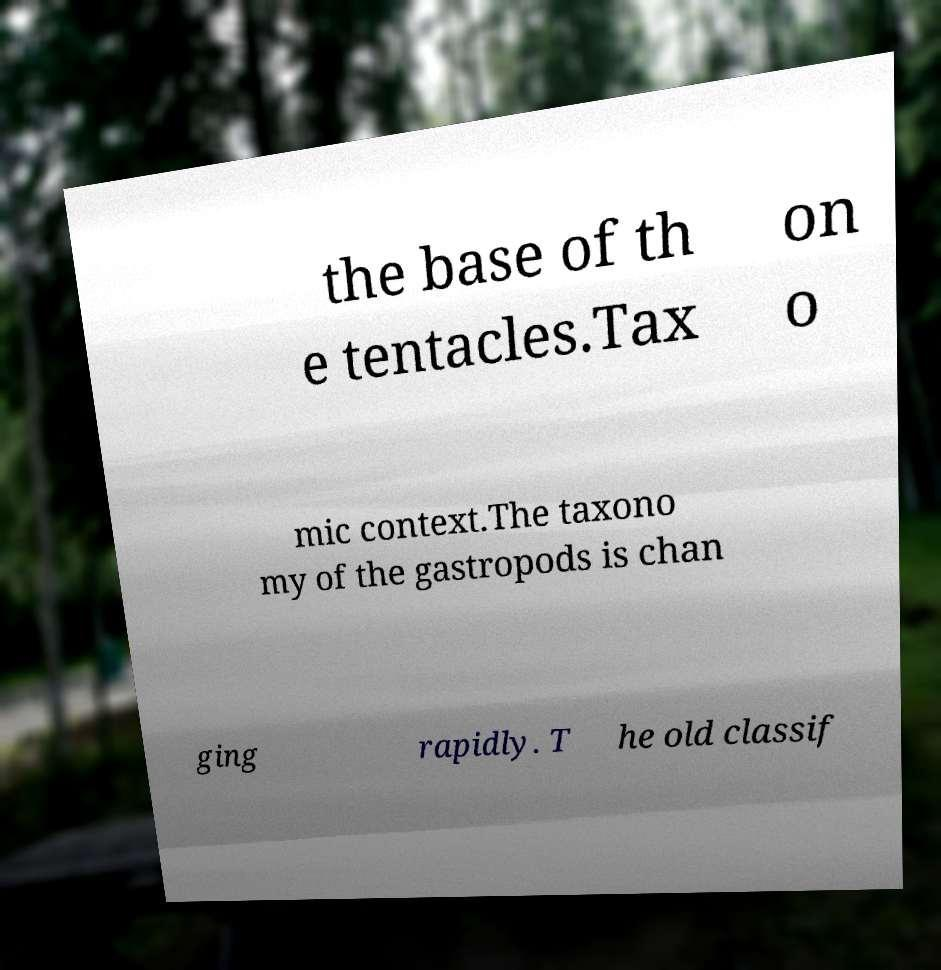Please read and relay the text visible in this image. What does it say? the base of th e tentacles.Tax on o mic context.The taxono my of the gastropods is chan ging rapidly. T he old classif 